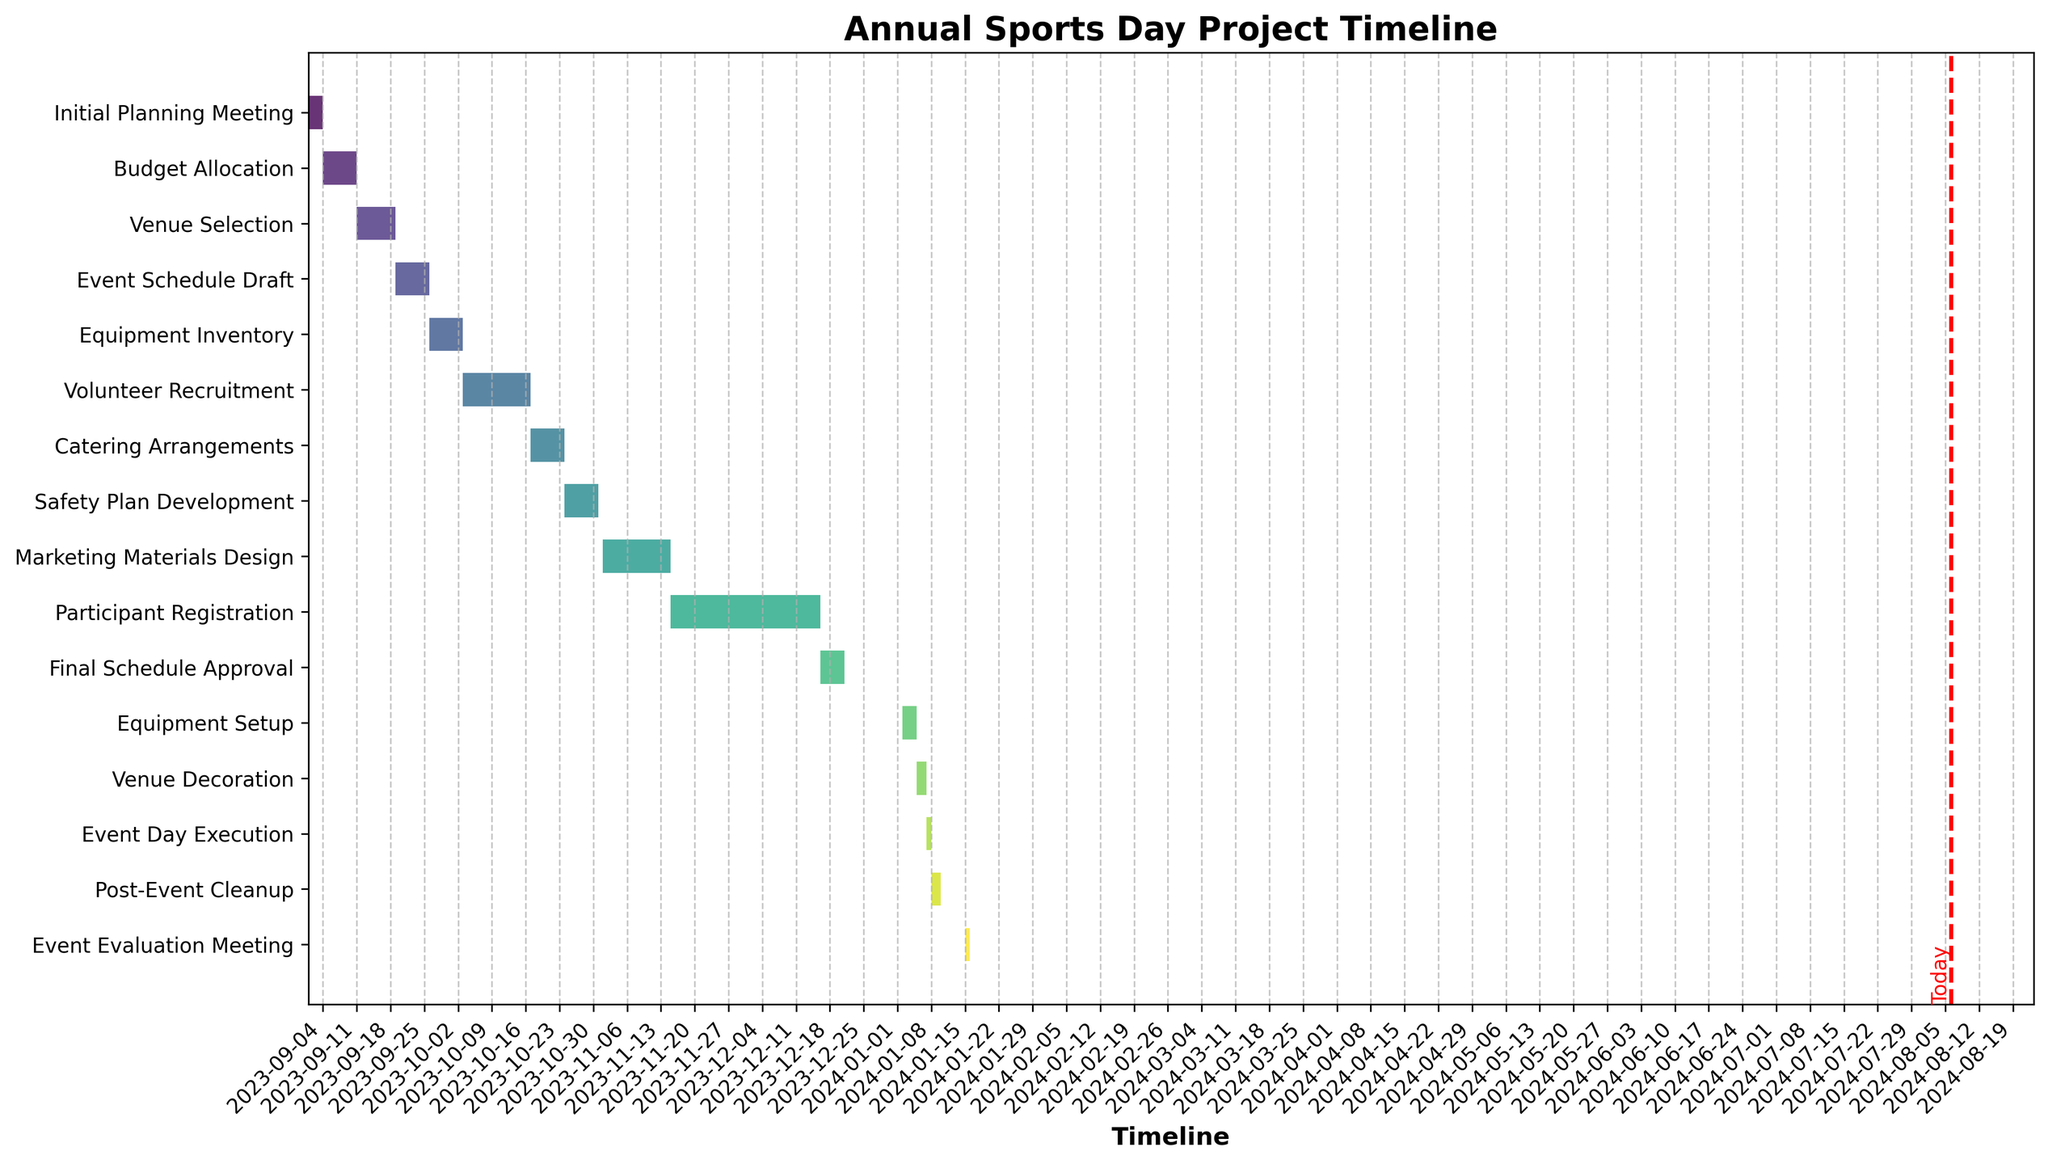What's the title of the Gantt Chart? The title is prominently displayed at the top of the figure. It provides a succinct description of what the chart is about.
Answer: Annual Sports Day Project Timeline What is depicted along the x-axis of the Gantt Chart? The x-axis shows the timeline, which includes dates formatted to be readable, tracking the progress from the start to the end of the project.
Answer: Timeline How many tasks are listed in the Gantt Chart? Count the number of horizontal bars or task names listed along the y-axis. Each bar represents a distinct task associated with the project timeline.
Answer: 15 tasks Which task has the longest duration? Identify the horizontal bar that spans the most dates along the x-axis. The task associated with this bar has the longest duration.
Answer: Participant Registration What task occurs immediately after "Venue Decoration"? Look for the "Venue Decoration" task and move to the subsequent bar listed immediately below it in the y-axis to find the next consecutive task.
Answer: Event Day Execution On what date does the "Final Schedule Approval" task start? Locate the "Final Schedule Approval" task and check the beginning of its associated horizontal bar on the x-axis to determine the start date.
Answer: 2023-12-16 Which task completes on the same day it starts? Look for the task whose horizontal bar spans just a single vertical line on the x-axis, indicating it starts and ends on the same day.
Answer: Event Day Execution How many tasks occur between the start and end of October 2023? Identify bars that lie between or intersect with the dates of October 1, 2023, and October 31, 2023. Count how many tasks fall within this date range.
Answer: 4 tasks What color represents the "Equipment Setup" task in the chart? Identify the "Equipment Setup" task on the y-axis and note its corresponding bar color, which is a part of the figure's visual encoding.
Answer: Specific color (e.g., a shade of green) How many days are allocated for the "Volunteer Recruitment" task? Find the "Volunteer Recruitment" task, then calculate the difference between its start and end dates plus one day to include both start and end dates in the count.
Answer: 14 days 